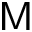Convert formula to latex. <formula><loc_0><loc_0><loc_500><loc_500>M</formula> 